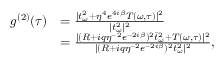Convert formula to latex. <formula><loc_0><loc_0><loc_500><loc_500>\begin{array} { r l } { g ^ { ( 2 ) } ( \tau ) } & { = \frac { | t _ { \omega } ^ { 2 } + \eta ^ { 4 } e ^ { 4 i \beta } T ( \omega , \tau ) | ^ { 2 } } { | t _ { \omega } ^ { 2 } | ^ { 2 } } } \\ & { = \frac { | ( R + i q \eta ^ { - 2 } e ^ { - 2 i \beta } ) ^ { 2 } \bar { t } _ { \omega } ^ { 2 } + T ( \omega , \tau ) | ^ { 2 } } { | ( R + i q \eta ^ { - 2 } e ^ { - 2 i \beta } ) ^ { 2 } \bar { t } _ { \omega } ^ { 2 } | ^ { 2 } } , } \end{array}</formula> 